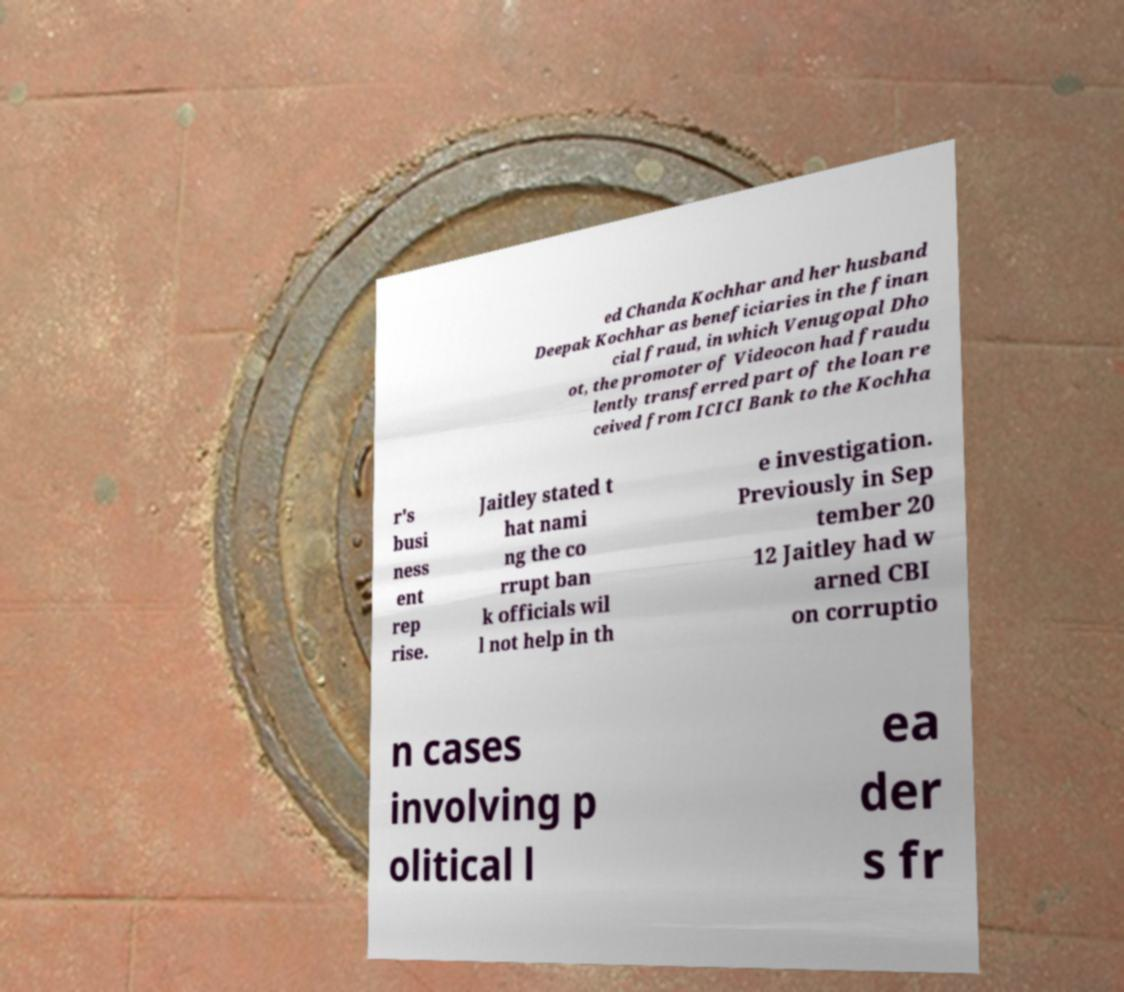There's text embedded in this image that I need extracted. Can you transcribe it verbatim? ed Chanda Kochhar and her husband Deepak Kochhar as beneficiaries in the finan cial fraud, in which Venugopal Dho ot, the promoter of Videocon had fraudu lently transferred part of the loan re ceived from ICICI Bank to the Kochha r's busi ness ent rep rise. Jaitley stated t hat nami ng the co rrupt ban k officials wil l not help in th e investigation. Previously in Sep tember 20 12 Jaitley had w arned CBI on corruptio n cases involving p olitical l ea der s fr 